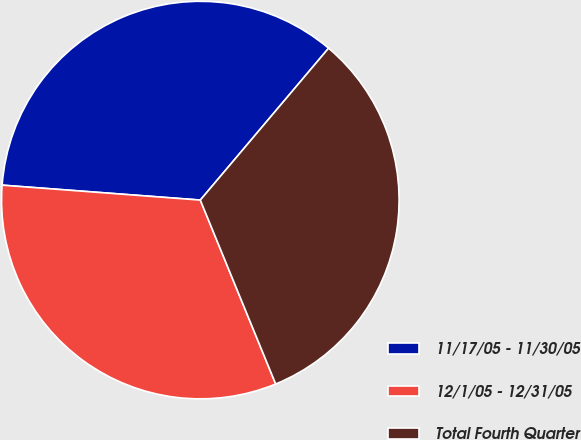<chart> <loc_0><loc_0><loc_500><loc_500><pie_chart><fcel>11/17/05 - 11/30/05<fcel>12/1/05 - 12/31/05<fcel>Total Fourth Quarter<nl><fcel>34.97%<fcel>32.39%<fcel>32.65%<nl></chart> 